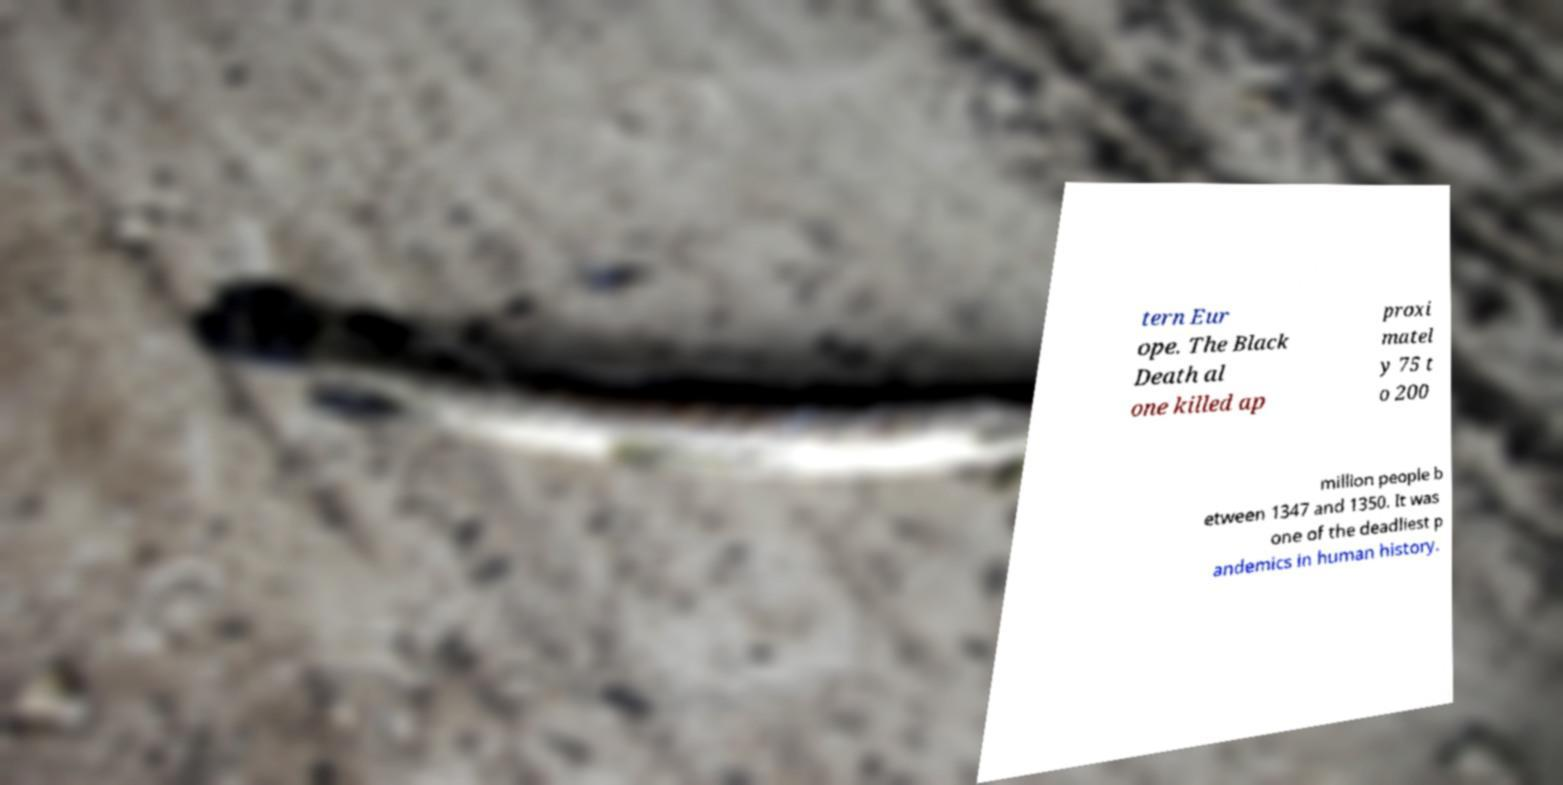There's text embedded in this image that I need extracted. Can you transcribe it verbatim? tern Eur ope. The Black Death al one killed ap proxi matel y 75 t o 200 million people b etween 1347 and 1350. It was one of the deadliest p andemics in human history. 